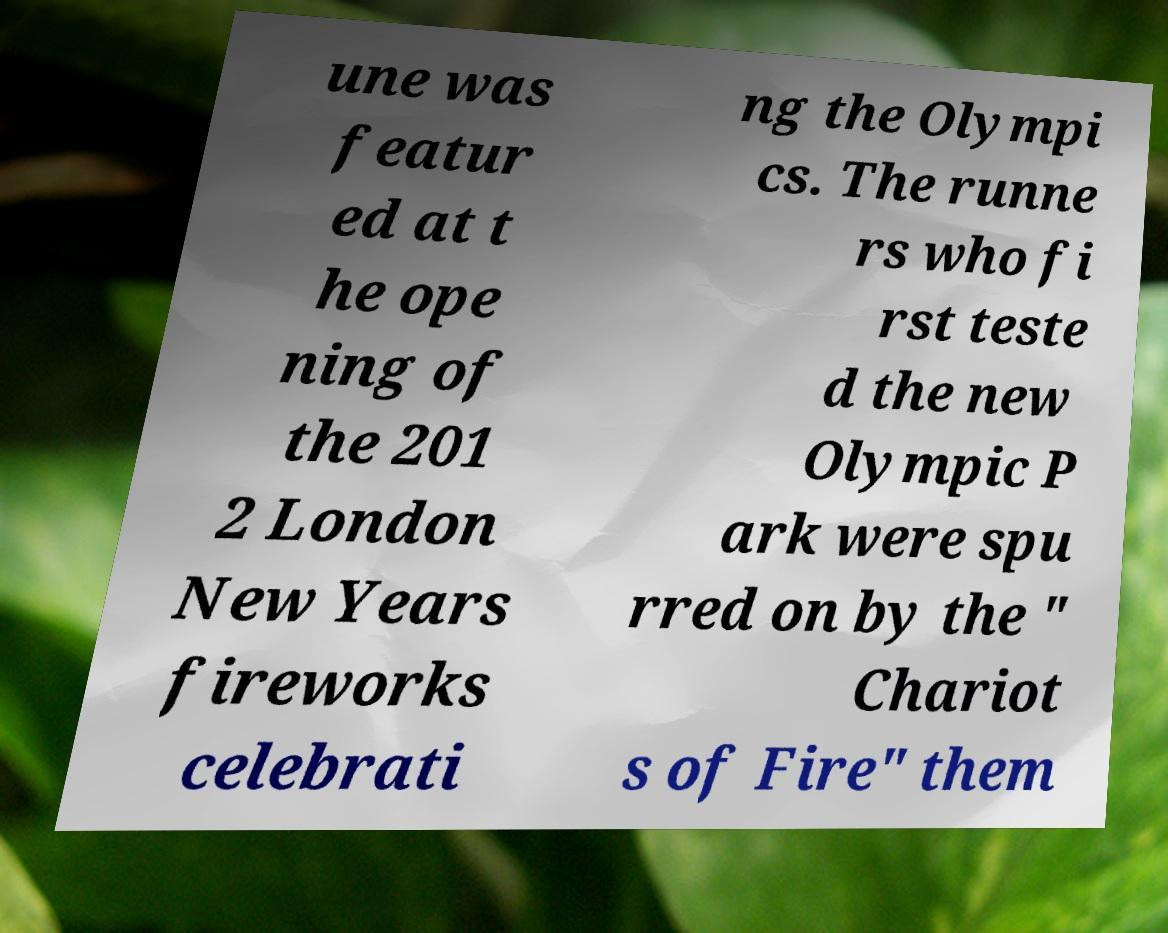Could you assist in decoding the text presented in this image and type it out clearly? une was featur ed at t he ope ning of the 201 2 London New Years fireworks celebrati ng the Olympi cs. The runne rs who fi rst teste d the new Olympic P ark were spu rred on by the " Chariot s of Fire" them 